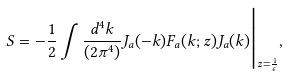Convert formula to latex. <formula><loc_0><loc_0><loc_500><loc_500>S = - \frac { 1 } { 2 } \int \frac { d ^ { 4 } k } { ( 2 \pi ^ { 4 } ) } J _ { a } ( - k ) F _ { a } ( k ; z ) J _ { a } ( k ) \Big | _ { z = \frac { 1 } { \epsilon } } ,</formula> 